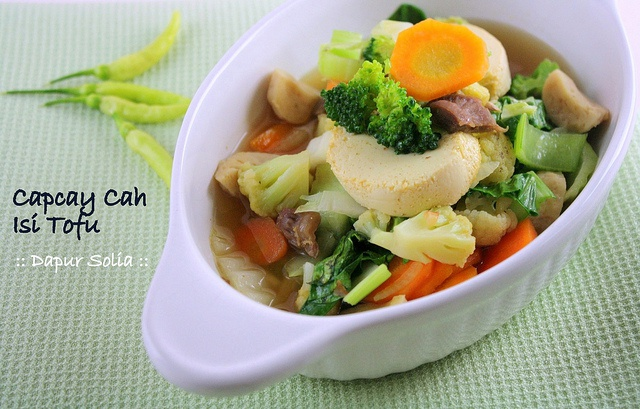Describe the objects in this image and their specific colors. I can see bowl in lavender, darkgray, tan, and olive tones, broccoli in lavender, khaki, tan, and olive tones, broccoli in lavender, black, darkgreen, and green tones, carrot in lavender, orange, and red tones, and carrot in lavender, brown, red, and maroon tones in this image. 